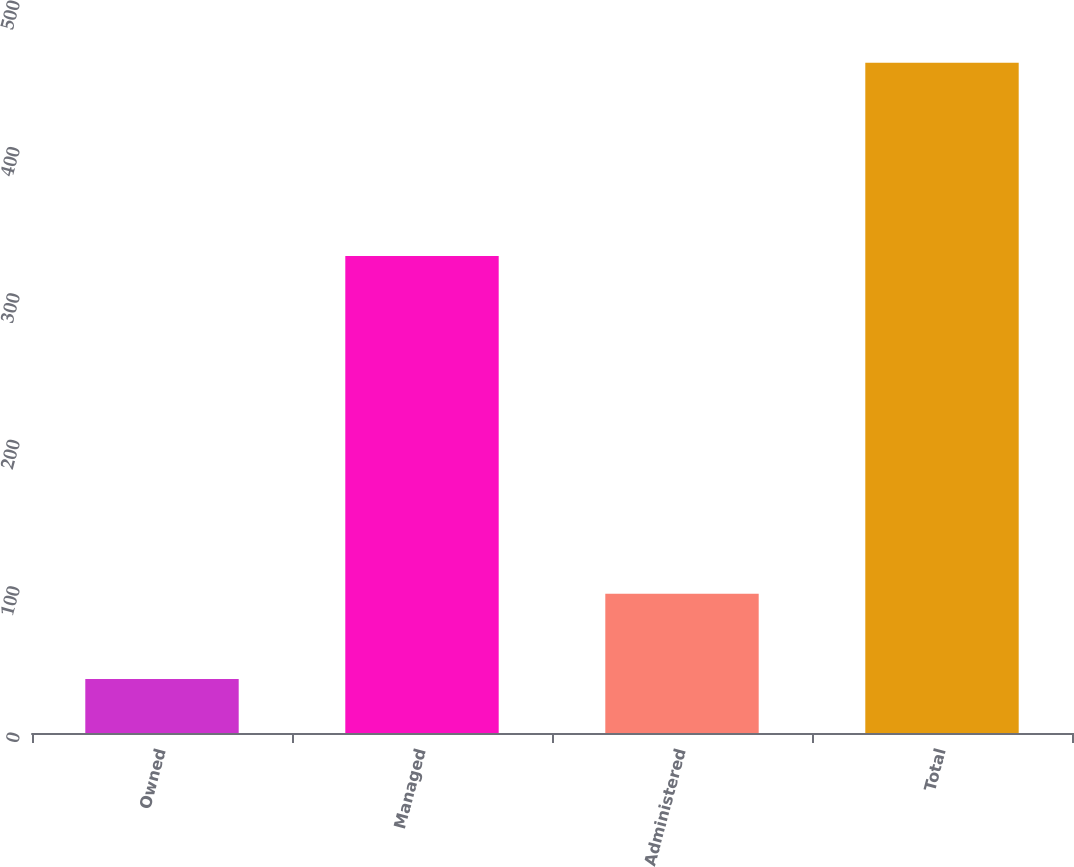Convert chart to OTSL. <chart><loc_0><loc_0><loc_500><loc_500><bar_chart><fcel>Owned<fcel>Managed<fcel>Administered<fcel>Total<nl><fcel>36.9<fcel>325.8<fcel>95.1<fcel>457.8<nl></chart> 